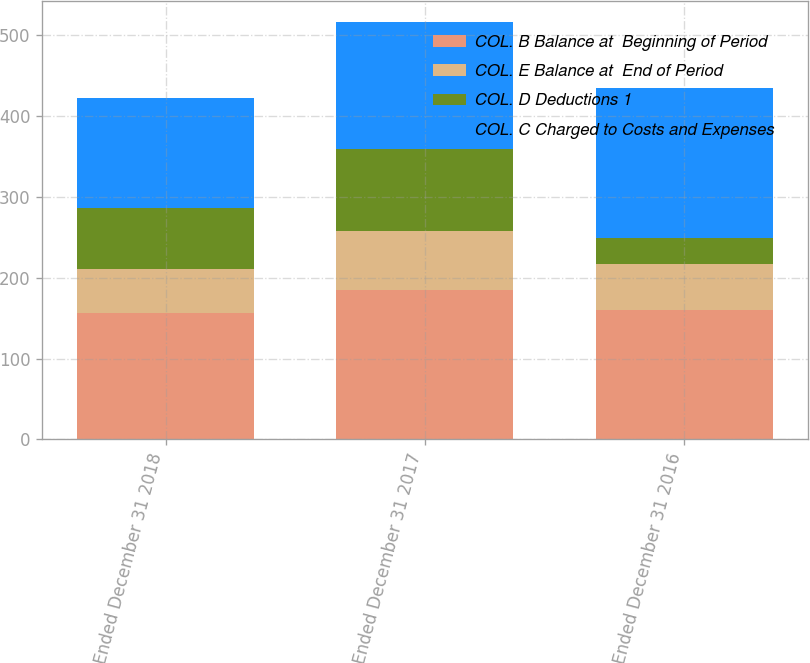Convert chart to OTSL. <chart><loc_0><loc_0><loc_500><loc_500><stacked_bar_chart><ecel><fcel>Year Ended December 31 2018<fcel>Year Ended December 31 2017<fcel>Year Ended December 31 2016<nl><fcel>COL. B Balance at  Beginning of Period<fcel>157<fcel>185<fcel>160<nl><fcel>COL. E Balance at  End of Period<fcel>54<fcel>73<fcel>57<nl><fcel>COL. D Deductions 1<fcel>75<fcel>101<fcel>32<nl><fcel>COL. C Charged to Costs and Expenses<fcel>136<fcel>157<fcel>185<nl></chart> 